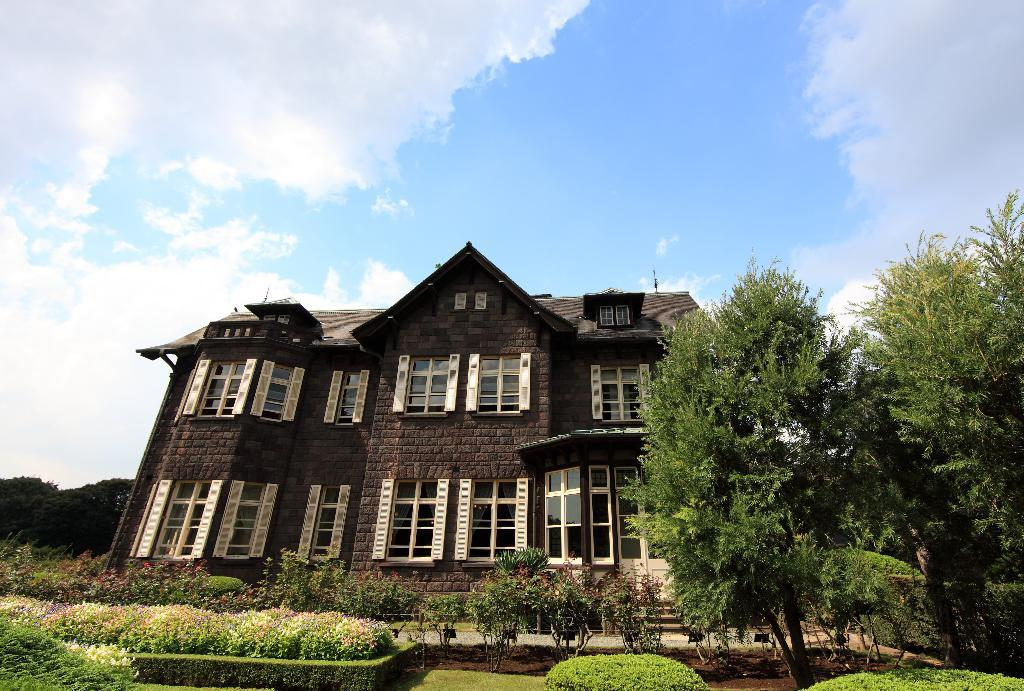What type of structure is present in the image? There is a house in the image. What can be seen around the house? There are plants and trees around the house. What feature of the house is mentioned in the facts? The house has windows. What part of the natural environment is visible in the image? The sky is visible in the image. How many balls are visible on the neck of the house in the image? There are no balls or necks present in the image; it features a house with plants, trees, windows, and a visible sky. 